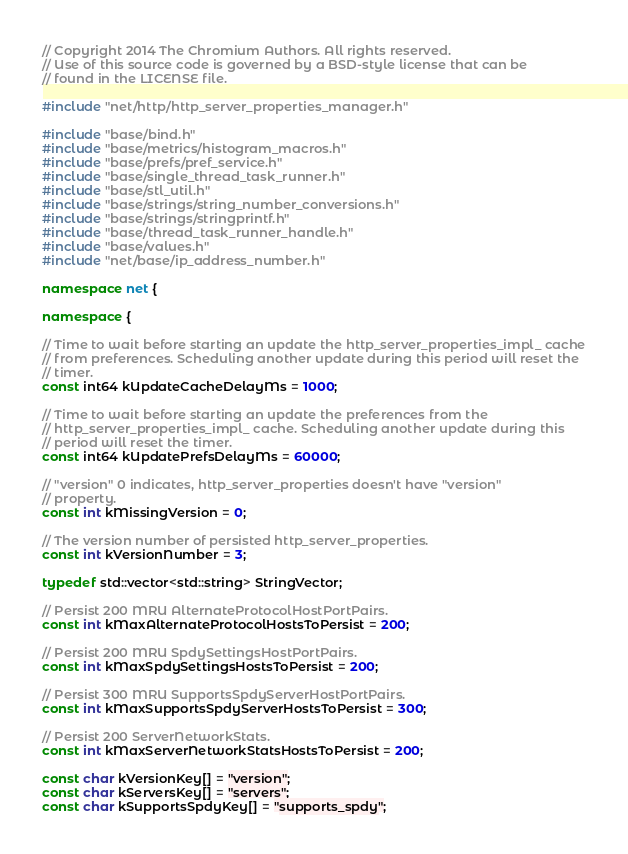<code> <loc_0><loc_0><loc_500><loc_500><_C++_>// Copyright 2014 The Chromium Authors. All rights reserved.
// Use of this source code is governed by a BSD-style license that can be
// found in the LICENSE file.

#include "net/http/http_server_properties_manager.h"

#include "base/bind.h"
#include "base/metrics/histogram_macros.h"
#include "base/prefs/pref_service.h"
#include "base/single_thread_task_runner.h"
#include "base/stl_util.h"
#include "base/strings/string_number_conversions.h"
#include "base/strings/stringprintf.h"
#include "base/thread_task_runner_handle.h"
#include "base/values.h"
#include "net/base/ip_address_number.h"

namespace net {

namespace {

// Time to wait before starting an update the http_server_properties_impl_ cache
// from preferences. Scheduling another update during this period will reset the
// timer.
const int64 kUpdateCacheDelayMs = 1000;

// Time to wait before starting an update the preferences from the
// http_server_properties_impl_ cache. Scheduling another update during this
// period will reset the timer.
const int64 kUpdatePrefsDelayMs = 60000;

// "version" 0 indicates, http_server_properties doesn't have "version"
// property.
const int kMissingVersion = 0;

// The version number of persisted http_server_properties.
const int kVersionNumber = 3;

typedef std::vector<std::string> StringVector;

// Persist 200 MRU AlternateProtocolHostPortPairs.
const int kMaxAlternateProtocolHostsToPersist = 200;

// Persist 200 MRU SpdySettingsHostPortPairs.
const int kMaxSpdySettingsHostsToPersist = 200;

// Persist 300 MRU SupportsSpdyServerHostPortPairs.
const int kMaxSupportsSpdyServerHostsToPersist = 300;

// Persist 200 ServerNetworkStats.
const int kMaxServerNetworkStatsHostsToPersist = 200;

const char kVersionKey[] = "version";
const char kServersKey[] = "servers";
const char kSupportsSpdyKey[] = "supports_spdy";</code> 